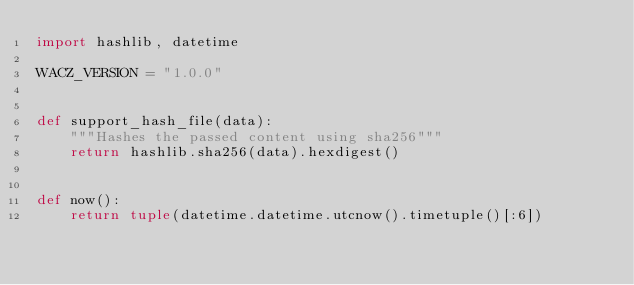<code> <loc_0><loc_0><loc_500><loc_500><_Python_>import hashlib, datetime

WACZ_VERSION = "1.0.0"


def support_hash_file(data):
    """Hashes the passed content using sha256"""
    return hashlib.sha256(data).hexdigest()


def now():
    return tuple(datetime.datetime.utcnow().timetuple()[:6])
</code> 